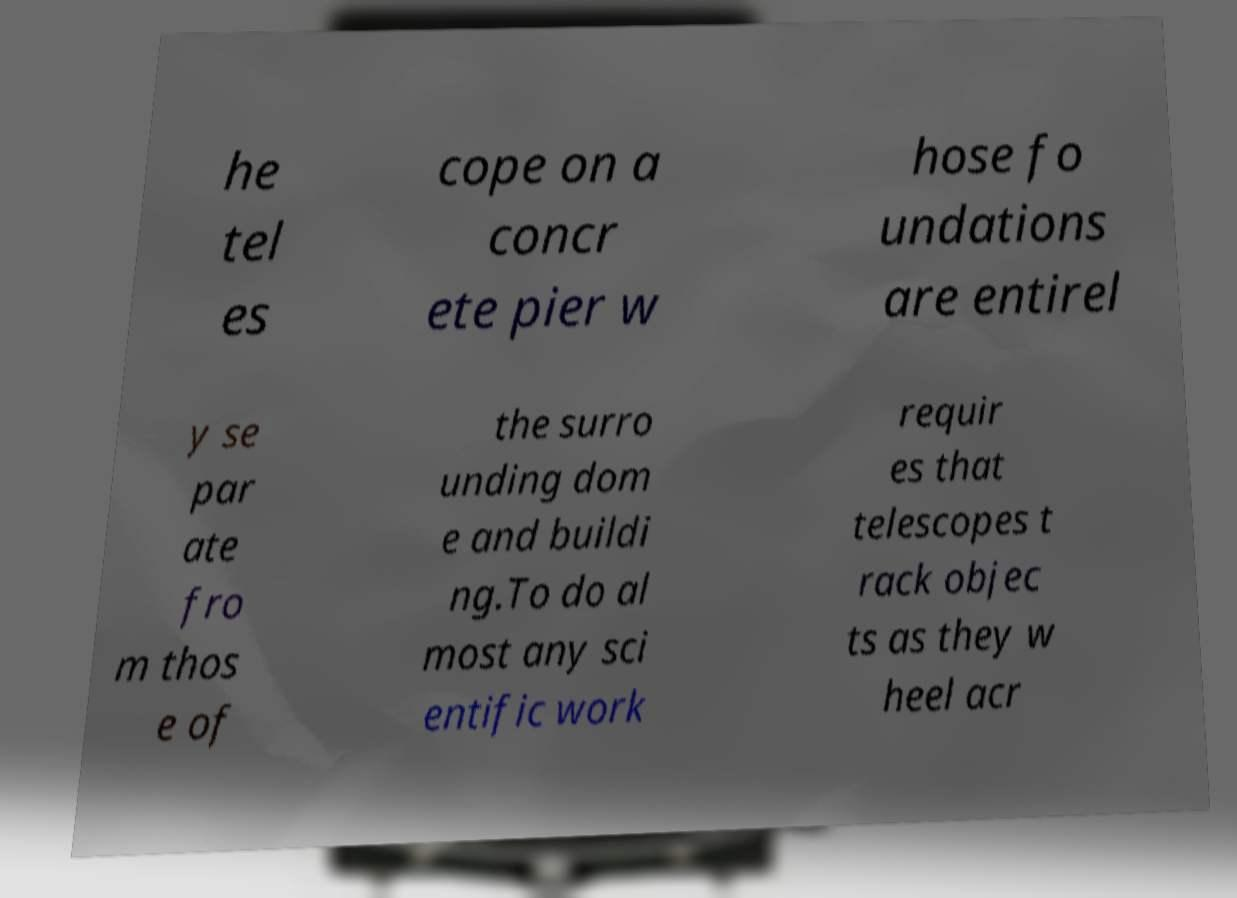There's text embedded in this image that I need extracted. Can you transcribe it verbatim? he tel es cope on a concr ete pier w hose fo undations are entirel y se par ate fro m thos e of the surro unding dom e and buildi ng.To do al most any sci entific work requir es that telescopes t rack objec ts as they w heel acr 